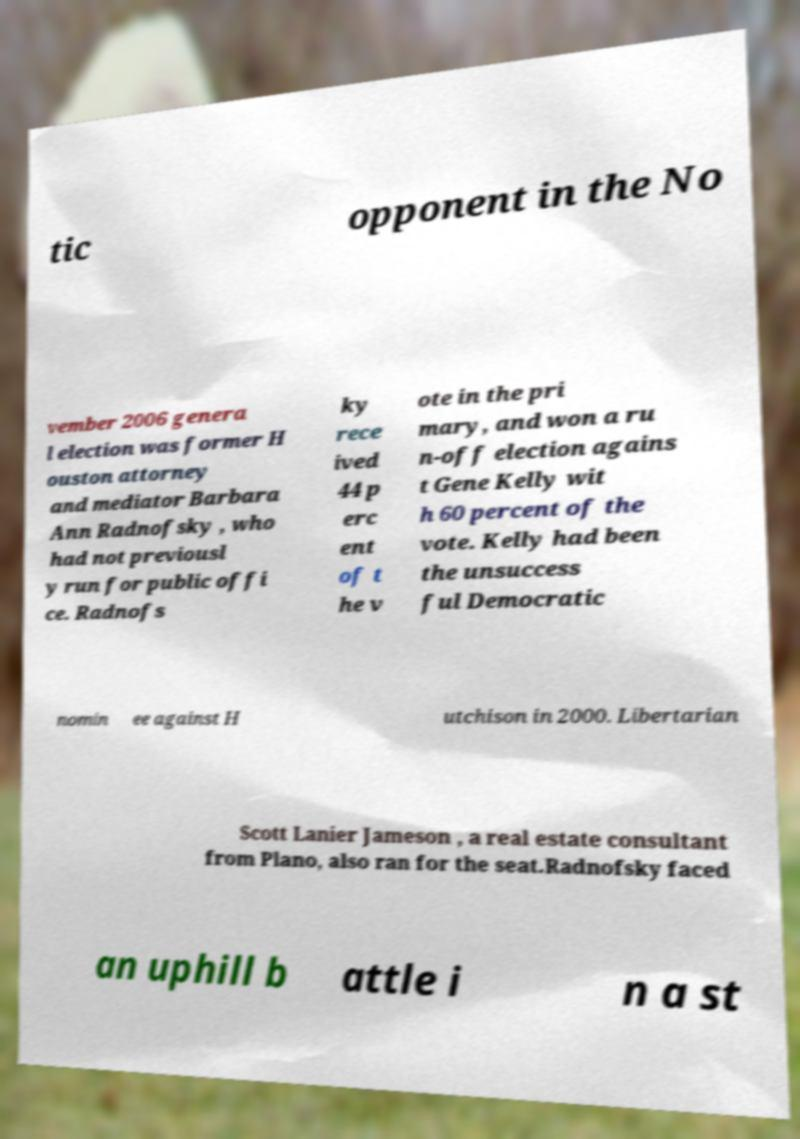What messages or text are displayed in this image? I need them in a readable, typed format. tic opponent in the No vember 2006 genera l election was former H ouston attorney and mediator Barbara Ann Radnofsky , who had not previousl y run for public offi ce. Radnofs ky rece ived 44 p erc ent of t he v ote in the pri mary, and won a ru n-off election agains t Gene Kelly wit h 60 percent of the vote. Kelly had been the unsuccess ful Democratic nomin ee against H utchison in 2000. Libertarian Scott Lanier Jameson , a real estate consultant from Plano, also ran for the seat.Radnofsky faced an uphill b attle i n a st 